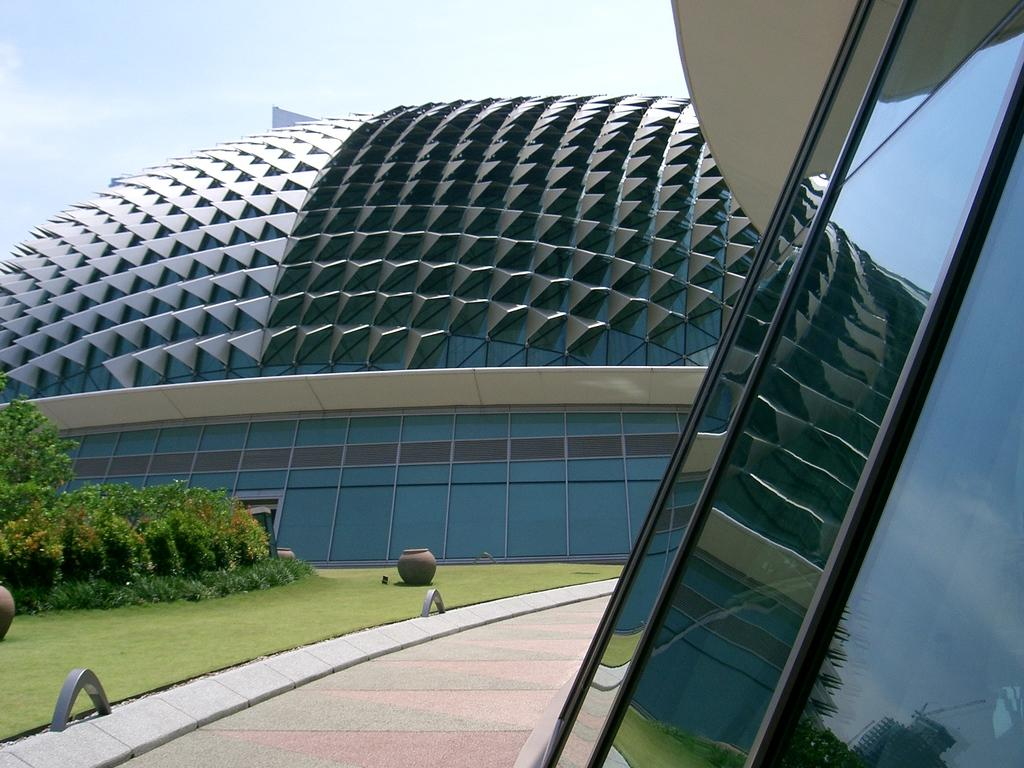What type of building is in the image? There is a glass building in the image. What can be seen on the left side of the image? There are plants, trees, grass, pots, and rods on the left side of the image. What is the purpose of the rods on the left side of the image? The purpose of the rods is not specified in the image, but they could be for support or decoration. What is the walkway used for in the image? The walkway is likely used for pedestrian access to or around the building. What is visible in the background of the image? The sky is visible in the background of the image. How many birds are sitting on the rods in the image? There are no birds present in the image; it only features a glass building, plants, trees, grass, pots, rods, a walkway, and the sky. 